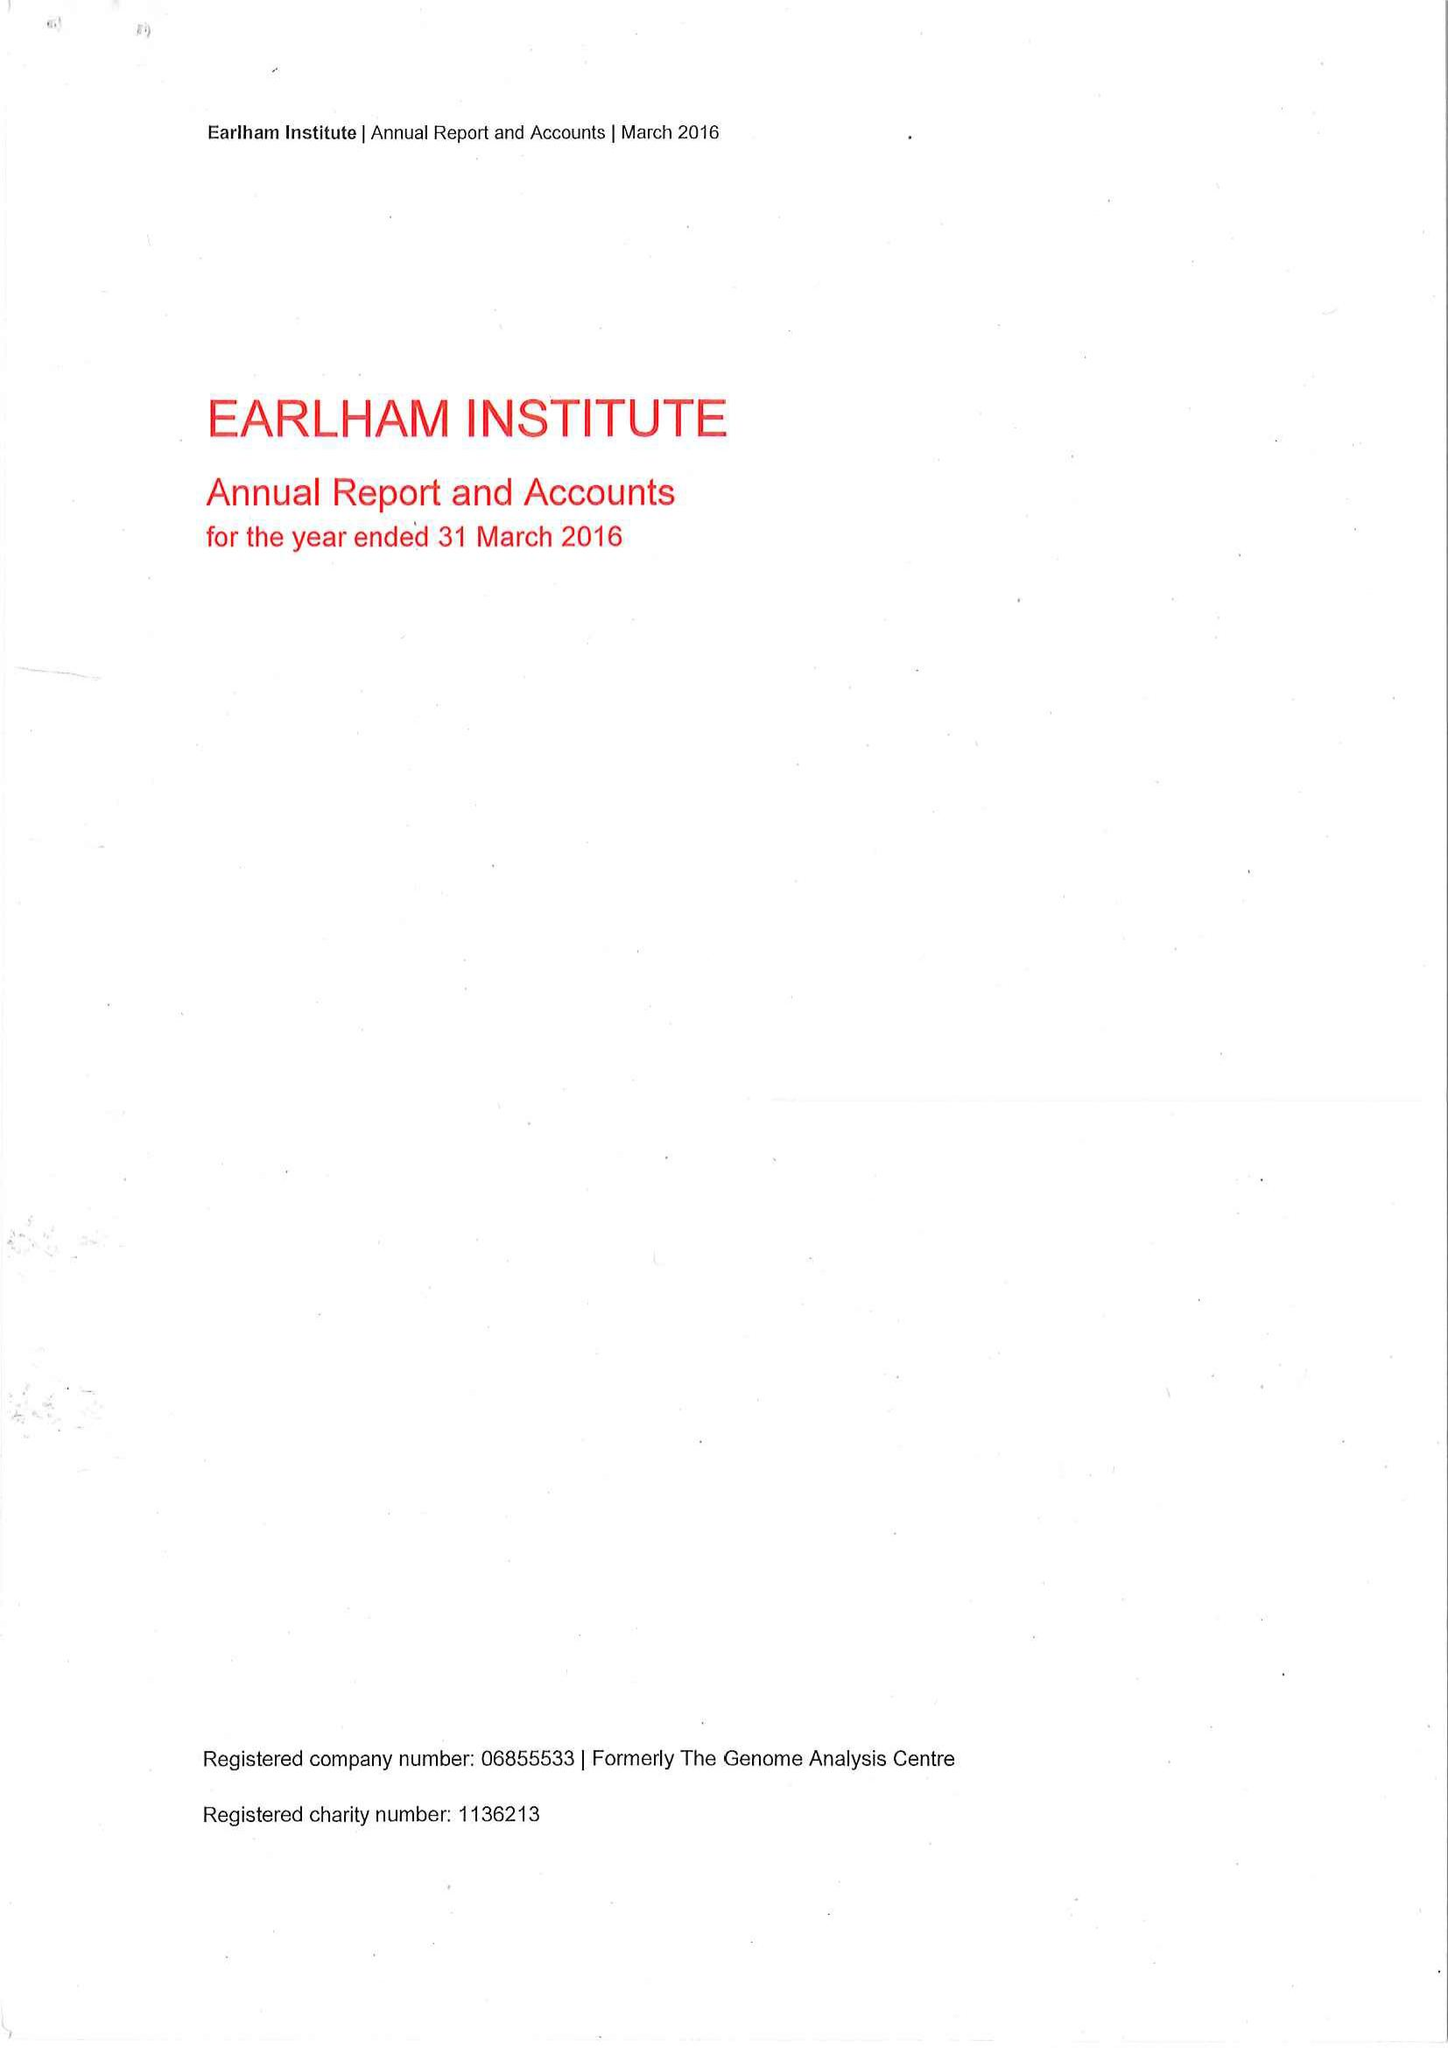What is the value for the address__post_town?
Answer the question using a single word or phrase. NORWICH 